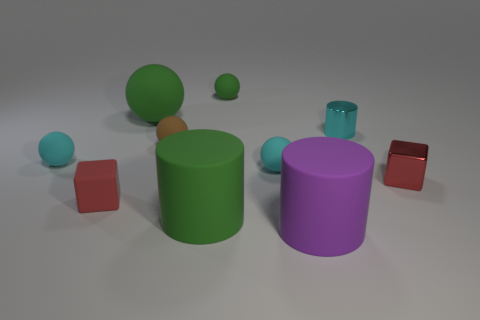Is the color of the rubber block the same as the small metallic block?
Provide a short and direct response. Yes. Are there more cylinders that are in front of the large purple object than large balls in front of the green cylinder?
Provide a succinct answer. No. Does the large purple cylinder have the same material as the red block to the right of the large ball?
Provide a short and direct response. No. What is the color of the small metal cube?
Provide a succinct answer. Red. The cyan rubber thing that is on the right side of the small green matte ball has what shape?
Keep it short and to the point. Sphere. What number of red objects are tiny matte objects or metal things?
Your answer should be very brief. 2. What color is the block that is the same material as the tiny brown thing?
Offer a terse response. Red. Is the color of the metallic cylinder the same as the matte ball that is to the right of the tiny green matte ball?
Your response must be concise. Yes. There is a ball that is in front of the small metallic cylinder and left of the small brown rubber ball; what color is it?
Give a very brief answer. Cyan. There is a big green cylinder; how many red shiny cubes are behind it?
Provide a succinct answer. 1. 